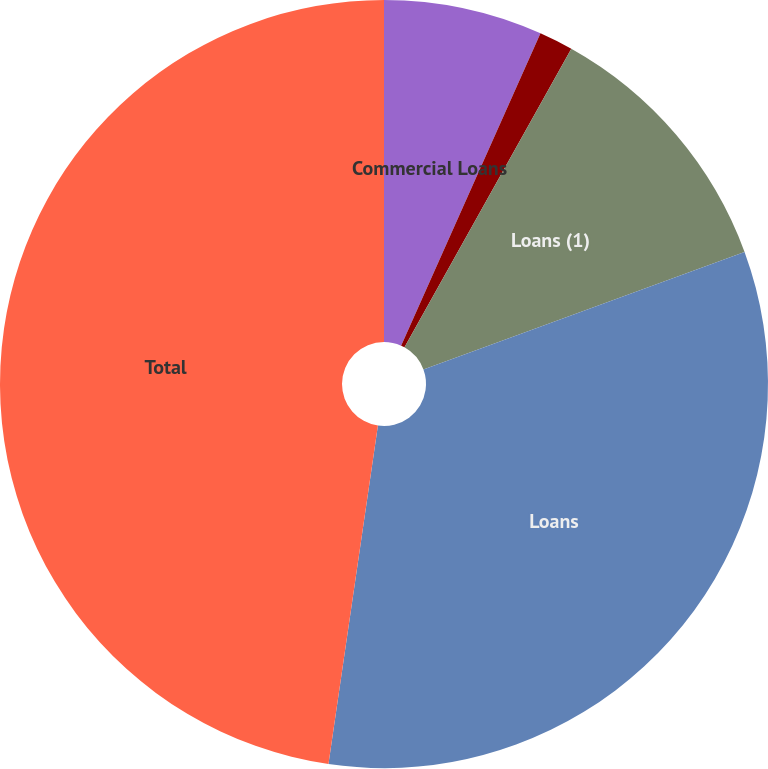<chart> <loc_0><loc_0><loc_500><loc_500><pie_chart><fcel>Commercial Loans<fcel>Construction Loans<fcel>Loans (1)<fcel>Loans<fcel>Total<nl><fcel>6.68%<fcel>1.43%<fcel>11.3%<fcel>32.9%<fcel>47.69%<nl></chart> 